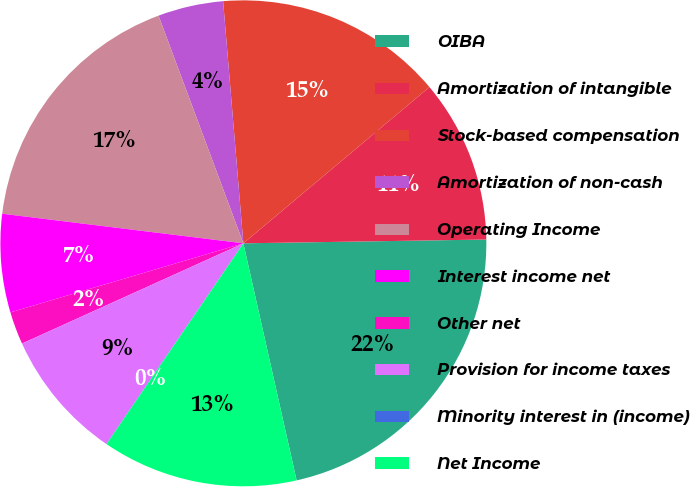Convert chart. <chart><loc_0><loc_0><loc_500><loc_500><pie_chart><fcel>OIBA<fcel>Amortization of intangible<fcel>Stock-based compensation<fcel>Amortization of non-cash<fcel>Operating Income<fcel>Interest income net<fcel>Other net<fcel>Provision for income taxes<fcel>Minority interest in (income)<fcel>Net Income<nl><fcel>21.73%<fcel>10.87%<fcel>15.21%<fcel>4.35%<fcel>17.38%<fcel>6.53%<fcel>2.18%<fcel>8.7%<fcel>0.01%<fcel>13.04%<nl></chart> 